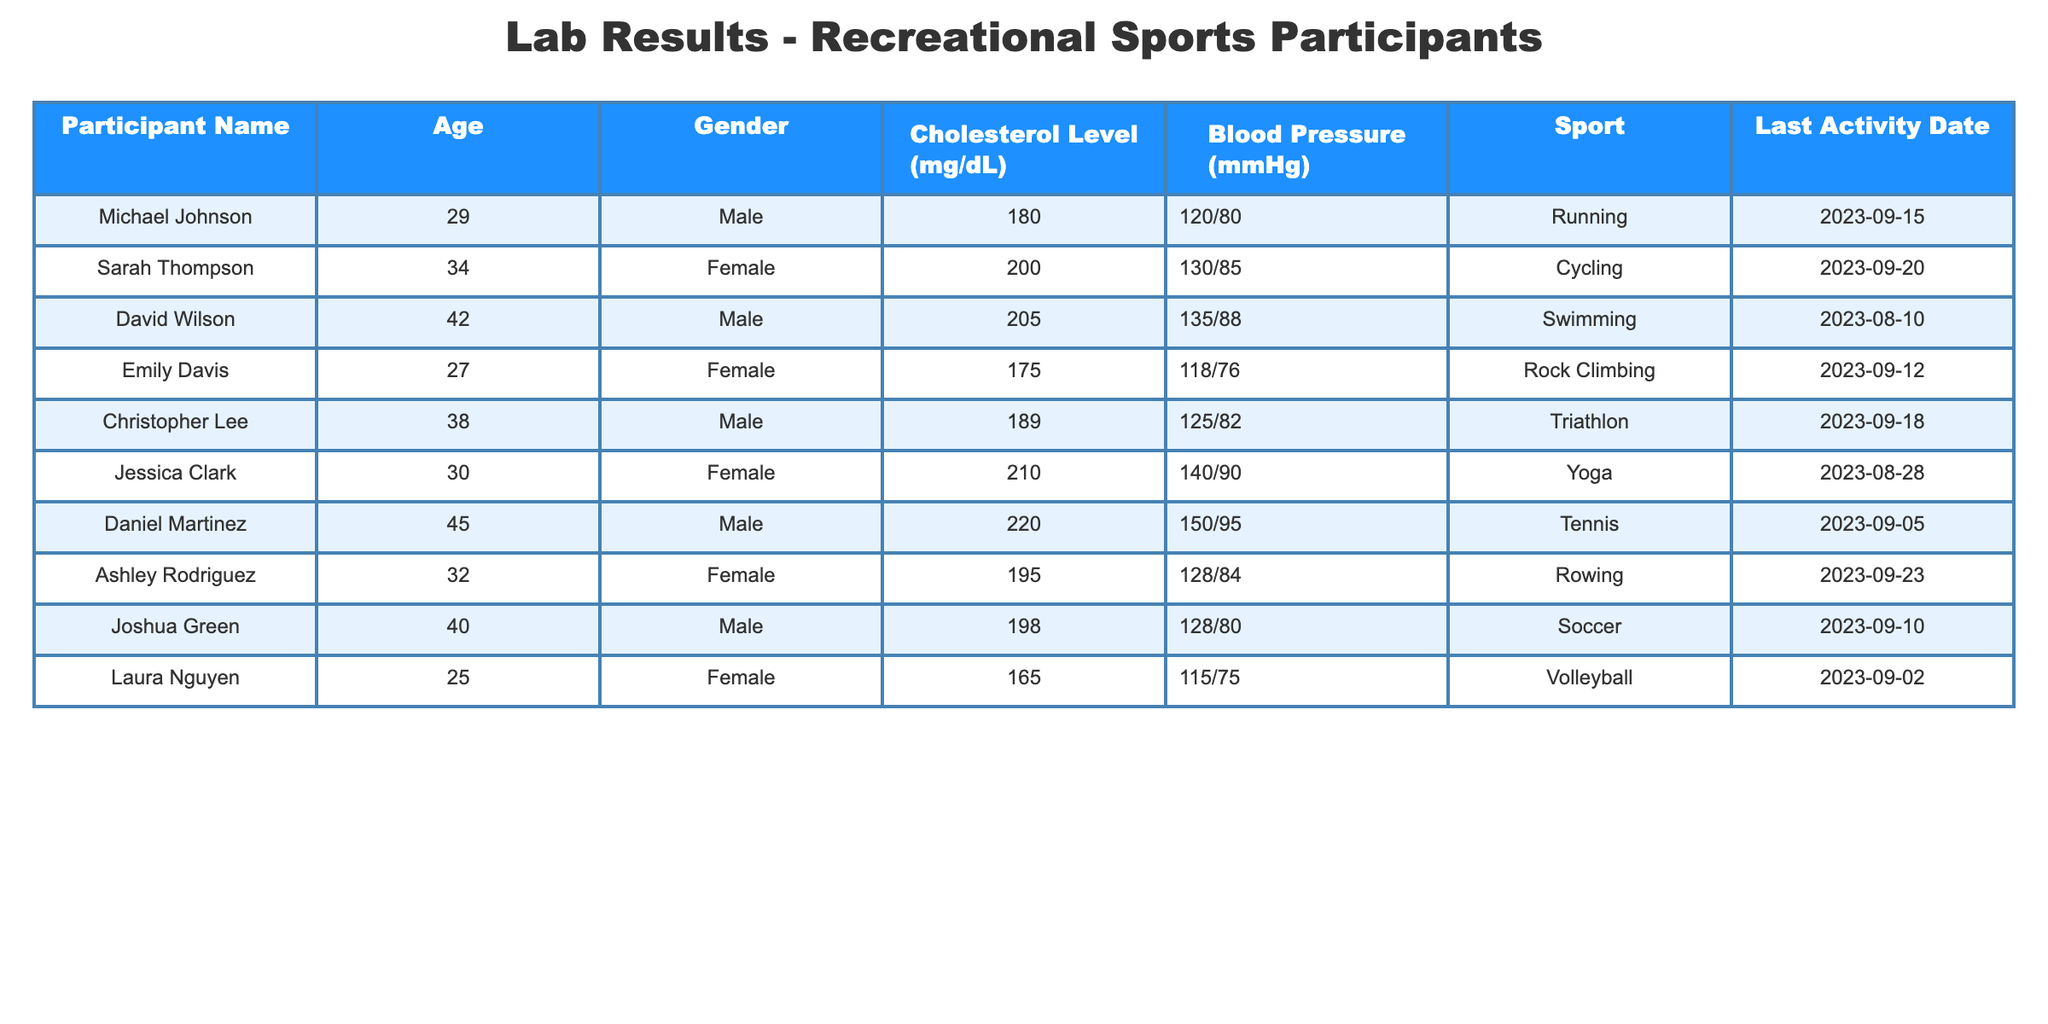What is the cholesterol level of Sarah Thompson? Sarah Thompson's cholesterol level is listed in the table under the "Cholesterol Level (mg/dL)" column. The table states her cholesterol level as 200 mg/dL.
Answer: 200 mg/dL What sport does Daniel Martinez participate in? The "Sport" column lists the activities associated with each participant. For Daniel Martinez, the table specifies that he participates in Tennis.
Answer: Tennis Who has the highest blood pressure reading among the participants? To determine this, we need to compare the blood pressure readings in the "Blood Pressure (mmHg)" column. By inspecting each entry, Daniel Martinez is listed with the highest reading of 150/95 mmHg.
Answer: Daniel Martinez What is the average cholesterol level of male participants? There are four male participants: Michael Johnson (180), David Wilson (205), Christopher Lee (189), and Daniel Martinez (220). Adding these together gives us 180 + 205 + 189 + 220 = 794. Dividing this sum by 4 gives an average of 794/4 = 198.5.
Answer: 198.5 Is there a female participant with a cholesterol level above 200 mg/dL? Looking at the "Cholesterol Level (mg/dL)" column for female participants, only Jessica Clark has a level of 210 mg/dL, which is above 200.
Answer: Yes What is the blood pressure reading of the youngest participant? The youngest participant is Laura Nguyen, who is 25 years old. Her blood pressure is recorded as 115/75 mmHg in the "Blood Pressure (mmHg)" column.
Answer: 115/75 mmHg List the names of participants whose cholesterol levels are in the range of 175 to 200 mg/dL. The cholesterol levels within this range apply to Michael Johnson (180), Emily Davis (175), Ashley Rodriguez (195), and Joshua Green (198). Therefore, their names are Michael Johnson, Emily Davis, Ashley Rodriguez, and Joshua Green.
Answer: Michael Johnson, Emily Davis, Ashley Rodriguez, Joshua Green How many participants have participated in any water-related sport? The "Sport" column indicates that only David Wilson (Swimming) and Joshua Green (Soccer, since soccer can be played in water activities) may involve water. Therefore, we count these participants. The total is 2.
Answer: 2 